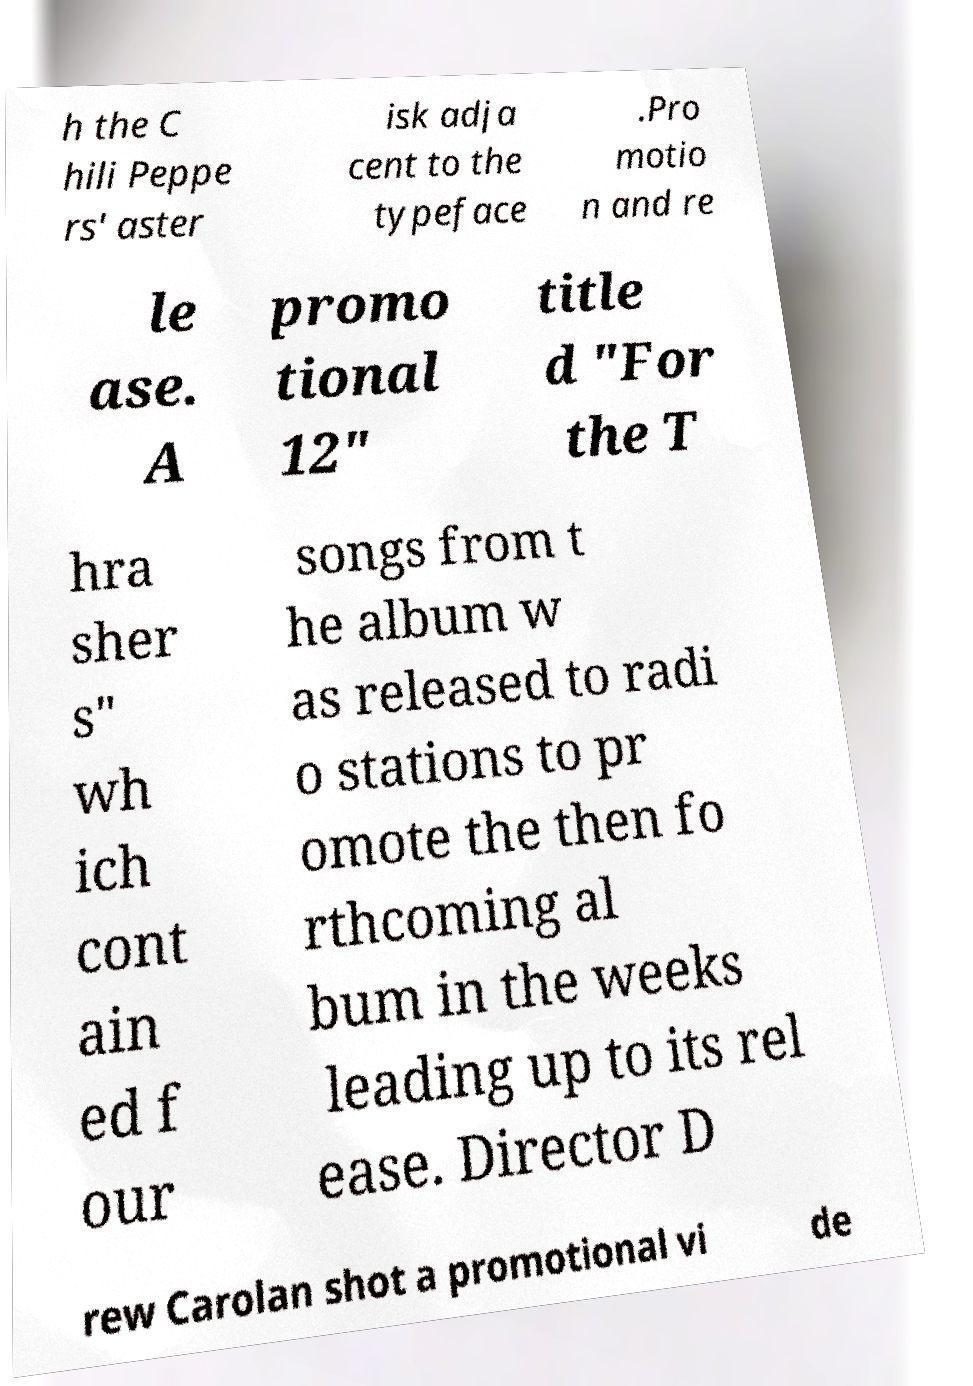There's text embedded in this image that I need extracted. Can you transcribe it verbatim? h the C hili Peppe rs' aster isk adja cent to the typeface .Pro motio n and re le ase. A promo tional 12" title d "For the T hra sher s" wh ich cont ain ed f our songs from t he album w as released to radi o stations to pr omote the then fo rthcoming al bum in the weeks leading up to its rel ease. Director D rew Carolan shot a promotional vi de 